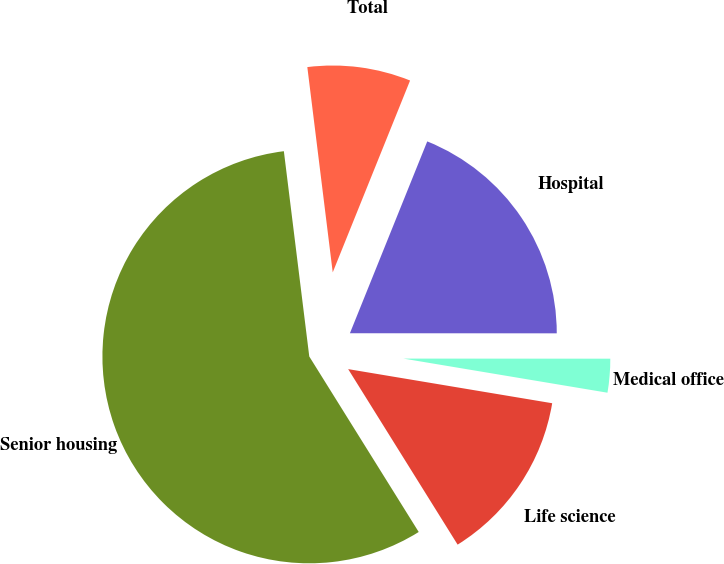Convert chart. <chart><loc_0><loc_0><loc_500><loc_500><pie_chart><fcel>Senior housing<fcel>Life science<fcel>Medical office<fcel>Hospital<fcel>Total<nl><fcel>56.92%<fcel>13.49%<fcel>2.63%<fcel>18.91%<fcel>8.06%<nl></chart> 